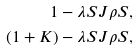<formula> <loc_0><loc_0><loc_500><loc_500>1 - \lambda S J \rho S , \\ ( 1 + K ) - \lambda S J \rho S ,</formula> 